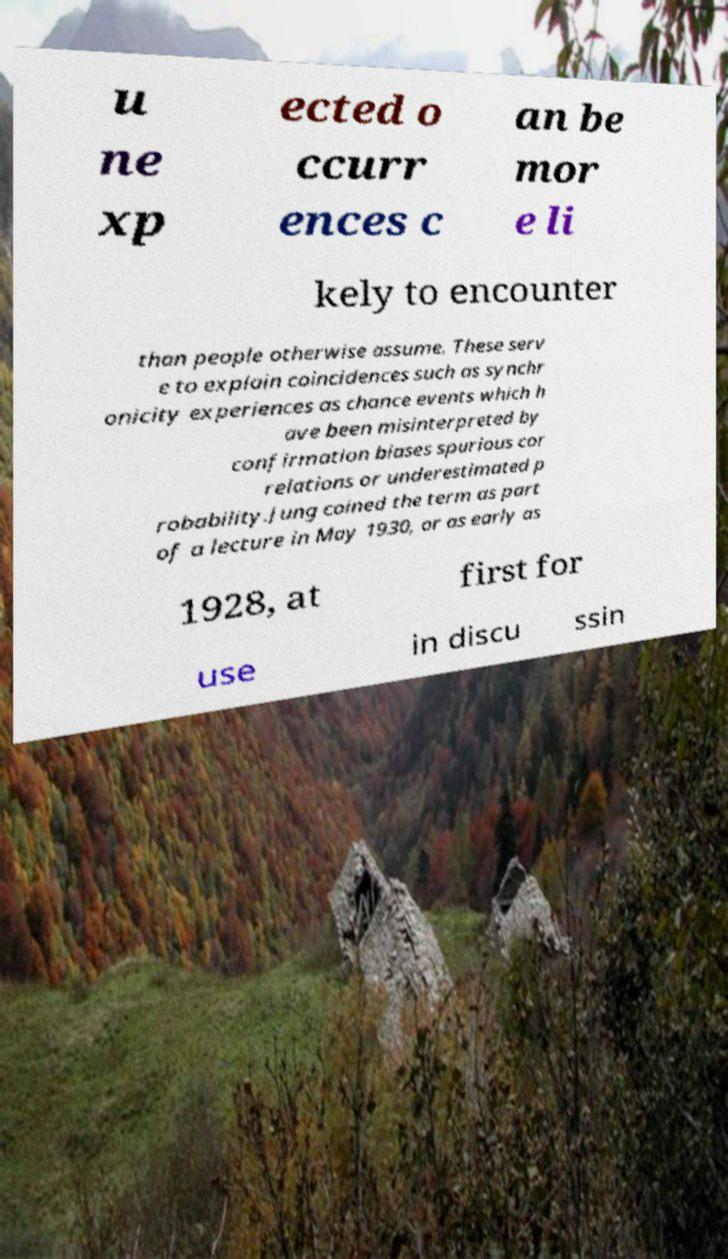Please read and relay the text visible in this image. What does it say? u ne xp ected o ccurr ences c an be mor e li kely to encounter than people otherwise assume. These serv e to explain coincidences such as synchr onicity experiences as chance events which h ave been misinterpreted by confirmation biases spurious cor relations or underestimated p robability.Jung coined the term as part of a lecture in May 1930, or as early as 1928, at first for use in discu ssin 